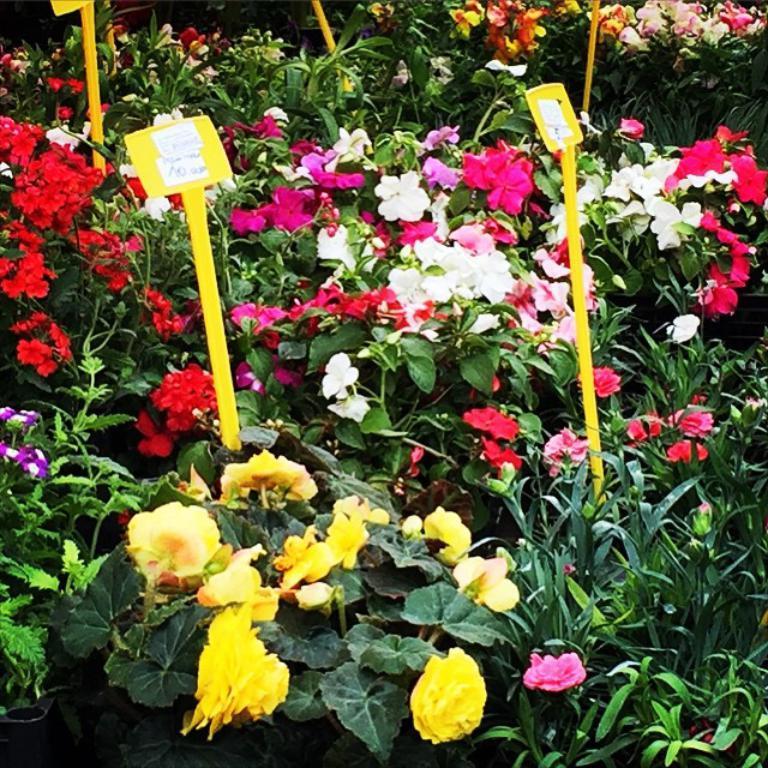Please provide a concise description of this image. In the picture we can see plants with a different kinds of flowers like yellow, white, red, pink and violet and to it we can see some yellow color tags with prices on it. 